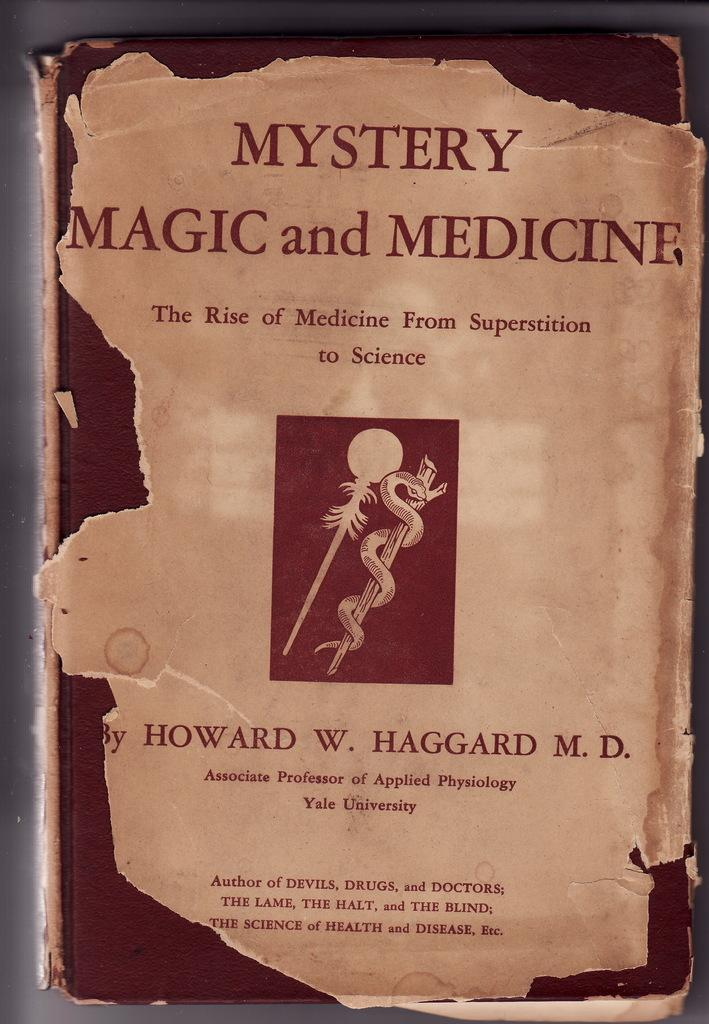<image>
Share a concise interpretation of the image provided. A book title page about medicine going from superstition to science lies on top of a book cover. 